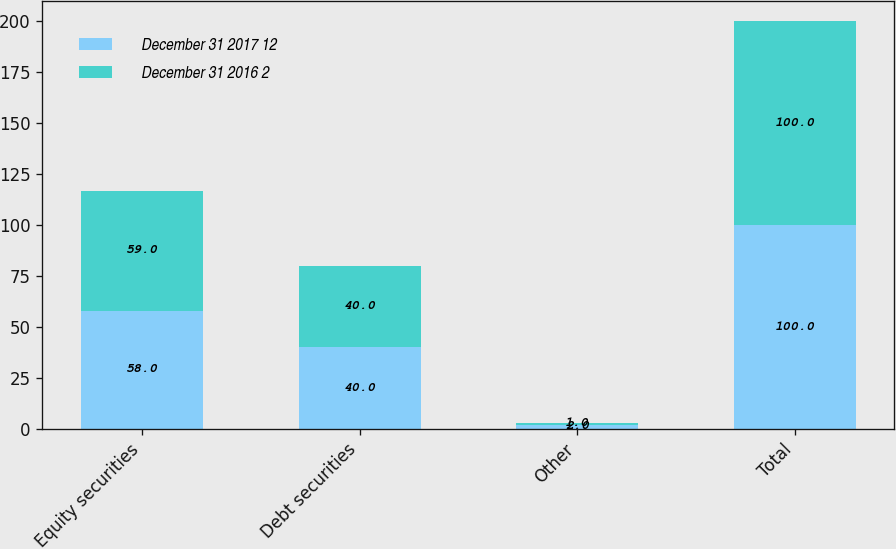Convert chart. <chart><loc_0><loc_0><loc_500><loc_500><stacked_bar_chart><ecel><fcel>Equity securities<fcel>Debt securities<fcel>Other<fcel>Total<nl><fcel>December 31 2017 12<fcel>58<fcel>40<fcel>2<fcel>100<nl><fcel>December 31 2016 2<fcel>59<fcel>40<fcel>1<fcel>100<nl></chart> 